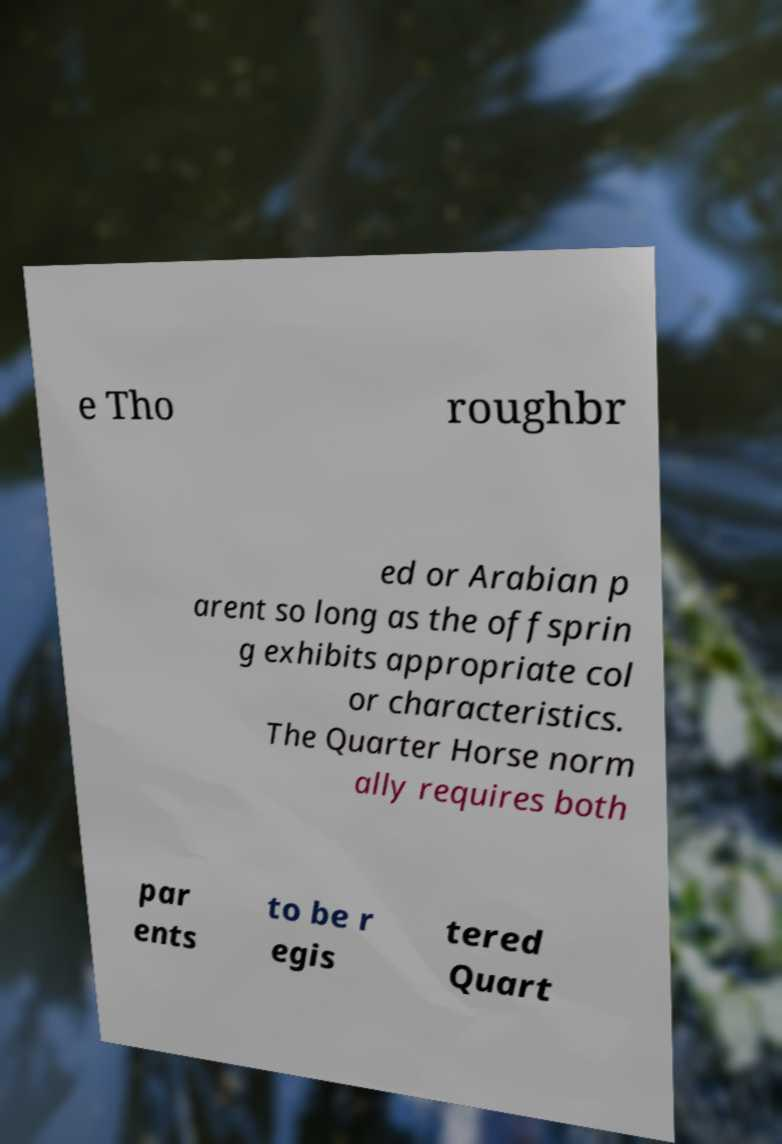Can you read and provide the text displayed in the image?This photo seems to have some interesting text. Can you extract and type it out for me? e Tho roughbr ed or Arabian p arent so long as the offsprin g exhibits appropriate col or characteristics. The Quarter Horse norm ally requires both par ents to be r egis tered Quart 